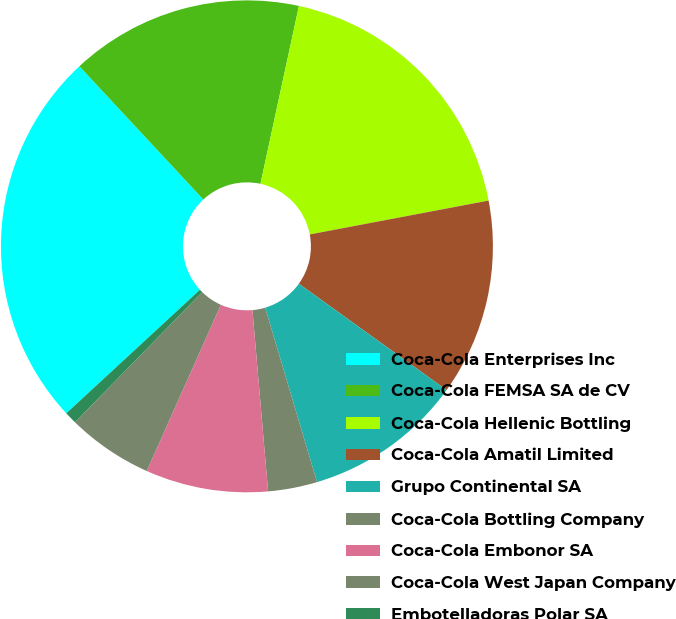Convert chart to OTSL. <chart><loc_0><loc_0><loc_500><loc_500><pie_chart><fcel>Coca-Cola Enterprises Inc<fcel>Coca-Cola FEMSA SA de CV<fcel>Coca-Cola Hellenic Bottling<fcel>Coca-Cola Amatil Limited<fcel>Grupo Continental SA<fcel>Coca-Cola Bottling Company<fcel>Coca-Cola Embonor SA<fcel>Coca-Cola West Japan Company<fcel>Embotelladoras Polar SA<nl><fcel>24.95%<fcel>15.32%<fcel>18.63%<fcel>12.91%<fcel>10.47%<fcel>3.23%<fcel>8.05%<fcel>5.64%<fcel>0.81%<nl></chart> 